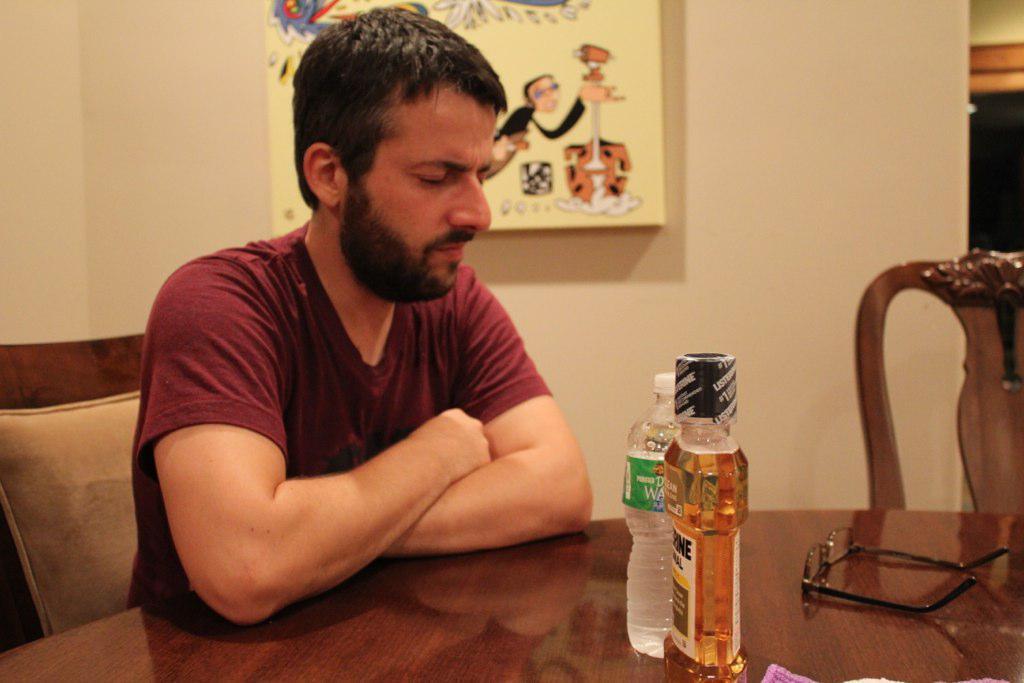Can you describe this image briefly? In this image we have a man sitting in the chair and in the table we have a water bottle, and the wine bottle , spectacles and at the back ground we have a wall in which a photo frame is attached. 